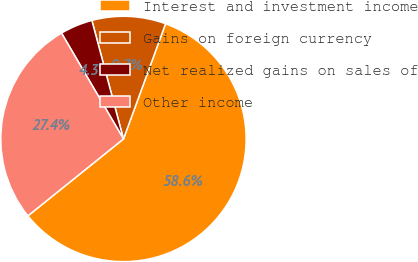Convert chart. <chart><loc_0><loc_0><loc_500><loc_500><pie_chart><fcel>Interest and investment income<fcel>Gains on foreign currency<fcel>Net realized gains on sales of<fcel>Other income<nl><fcel>58.64%<fcel>9.72%<fcel>4.28%<fcel>27.36%<nl></chart> 